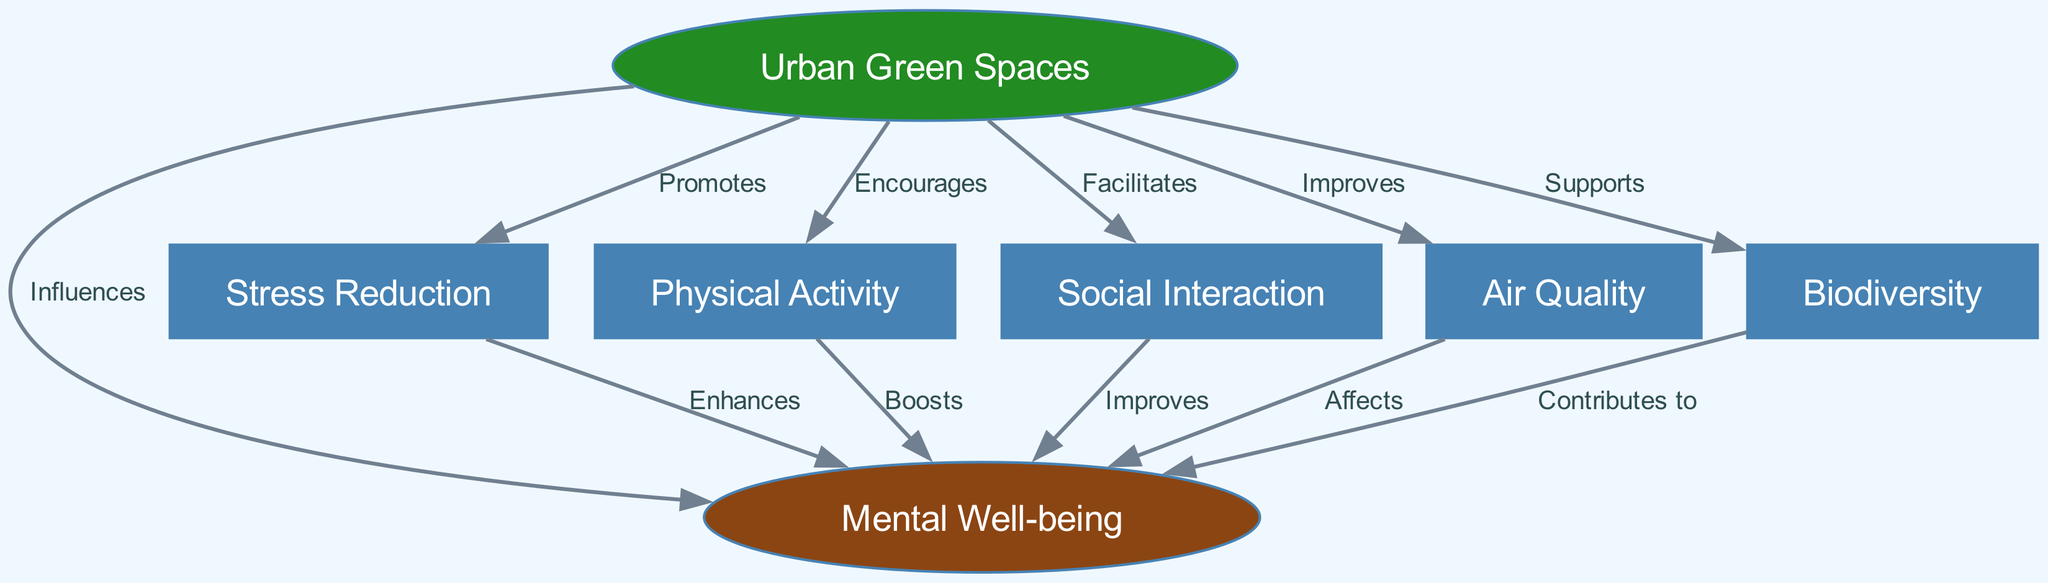What is the main focus of the diagram? The main focus of the diagram is the relationship between urban green spaces and mental well-being.
Answer: Urban Green Spaces and Mental Well-being How many nodes are present in the diagram? By counting the individual nodes in the diagram, there are a total of seven nodes depicted.
Answer: 7 What type of relationship exists between urban green spaces and mental well-being? The relationship is indicated by the label 'Influences' showing that urban green spaces have a positive effect on mental well-being.
Answer: Influences Which node promotes stress reduction? The node identified as 'Urban Green Spaces' is shown to have a direct influence on promoting stress reduction.
Answer: Urban Green Spaces What role does physical activity play in the diagram? Physical activity has a direct link to enhancing mental well-being, indicated by the label 'Boosts.'
Answer: Boosts How does social interaction affect mental well-being? It is displayed as 'Improves,' showing that social interaction contributes positively to mental well-being.
Answer: Improves Which factor contributes to mental well-being directly from biodiversity? The diagram indicates that biodiversity contributes to mental well-being, as shown by the label 'Contributes to.'
Answer: Contributes to Which two factors are connected through the label 'Enhances'? The two factors are stress reduction and mental well-being, with stress reduction enhancing mental well-being.
Answer: Stress Reduction and Mental Well-being How many edges are there in the diagram? The total number of edges can be counted in the diagram, which links the nodes together constitutively, and there are twelve edges.
Answer: 12 